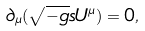Convert formula to latex. <formula><loc_0><loc_0><loc_500><loc_500>\partial _ { \mu } ( \sqrt { - g } s U ^ { \mu } ) = 0 ,</formula> 